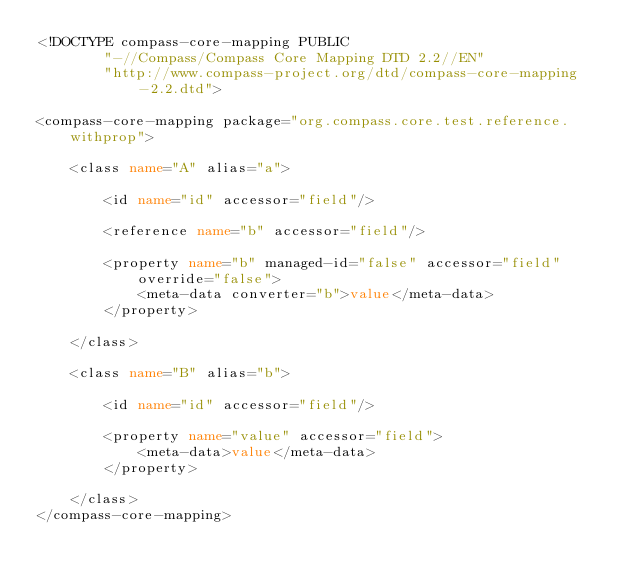<code> <loc_0><loc_0><loc_500><loc_500><_XML_><!DOCTYPE compass-core-mapping PUBLIC
        "-//Compass/Compass Core Mapping DTD 2.2//EN"
        "http://www.compass-project.org/dtd/compass-core-mapping-2.2.dtd">

<compass-core-mapping package="org.compass.core.test.reference.withprop">

    <class name="A" alias="a">

        <id name="id" accessor="field"/>

        <reference name="b" accessor="field"/>

        <property name="b" managed-id="false" accessor="field" override="false">
            <meta-data converter="b">value</meta-data>
        </property>

    </class>

    <class name="B" alias="b">

        <id name="id" accessor="field"/>

        <property name="value" accessor="field">
            <meta-data>value</meta-data>
        </property>

    </class>
</compass-core-mapping>
</code> 